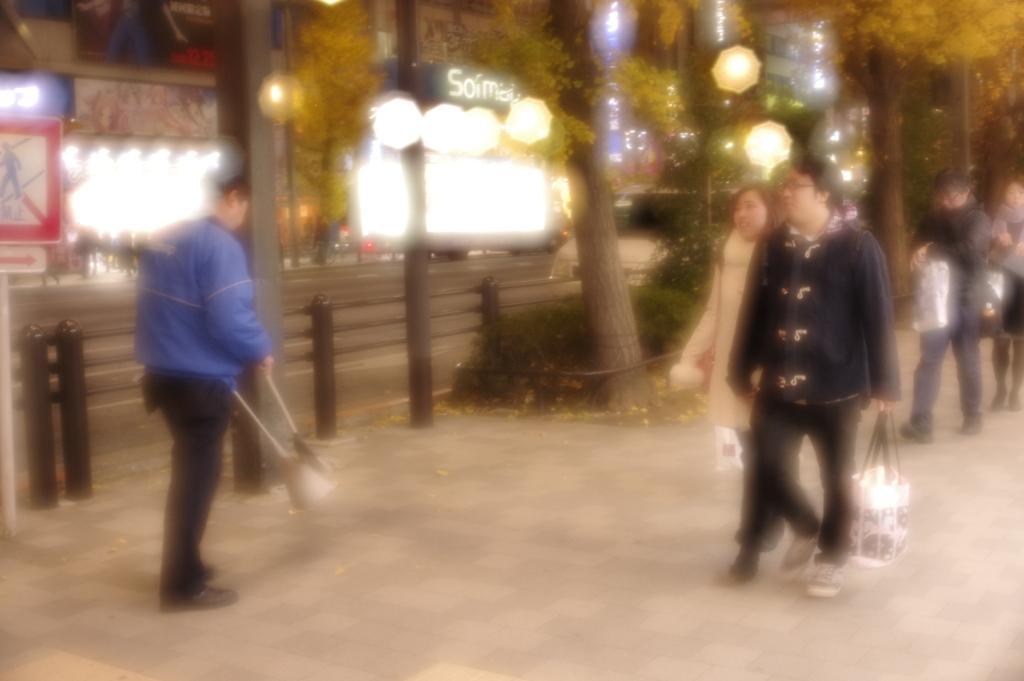Please provide a concise description of this image. In this picture I can see a man on the left side. On the right side few persons are walking, in the middle there are trees, lights and buildings with boards. 